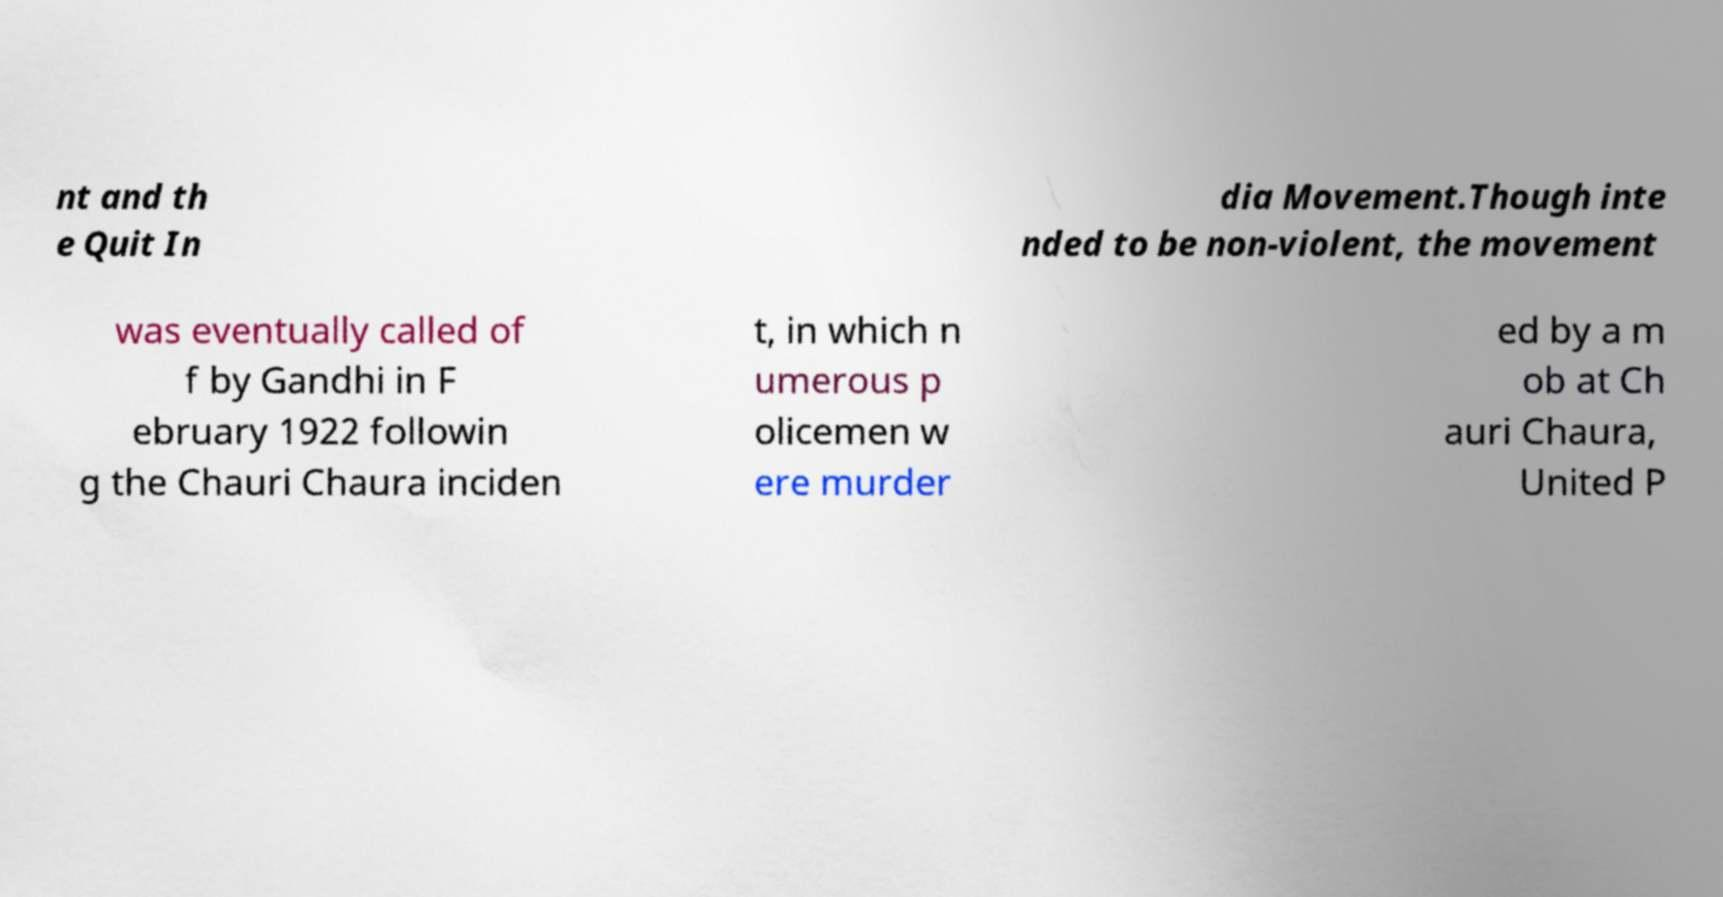Please read and relay the text visible in this image. What does it say? nt and th e Quit In dia Movement.Though inte nded to be non-violent, the movement was eventually called of f by Gandhi in F ebruary 1922 followin g the Chauri Chaura inciden t, in which n umerous p olicemen w ere murder ed by a m ob at Ch auri Chaura, United P 